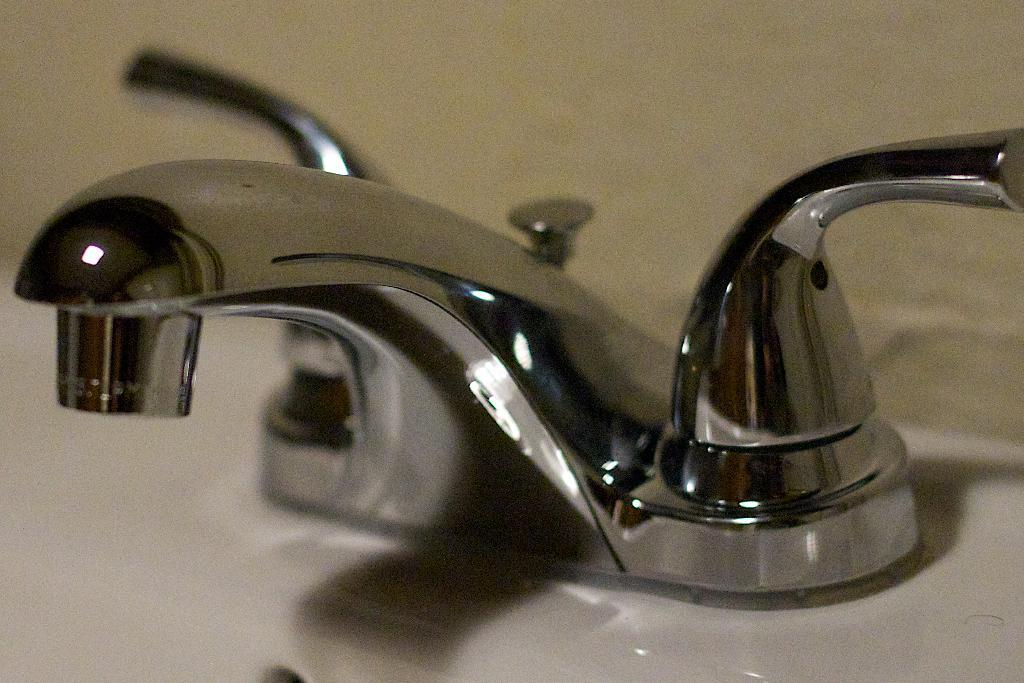What can be found in the image that is used for washing or cleaning? There is a sink in the image that can be used for washing or cleaning. What feature of the sink is mentioned in the facts? The sink has taps. What can be seen in the background of the image? There is a wall in the background of the image. What type of linen is draped over the airplane in the image? There is no airplane or linen present in the image. How does the sail affect the movement of the boat in the image? There is no boat or sail present in the image. 